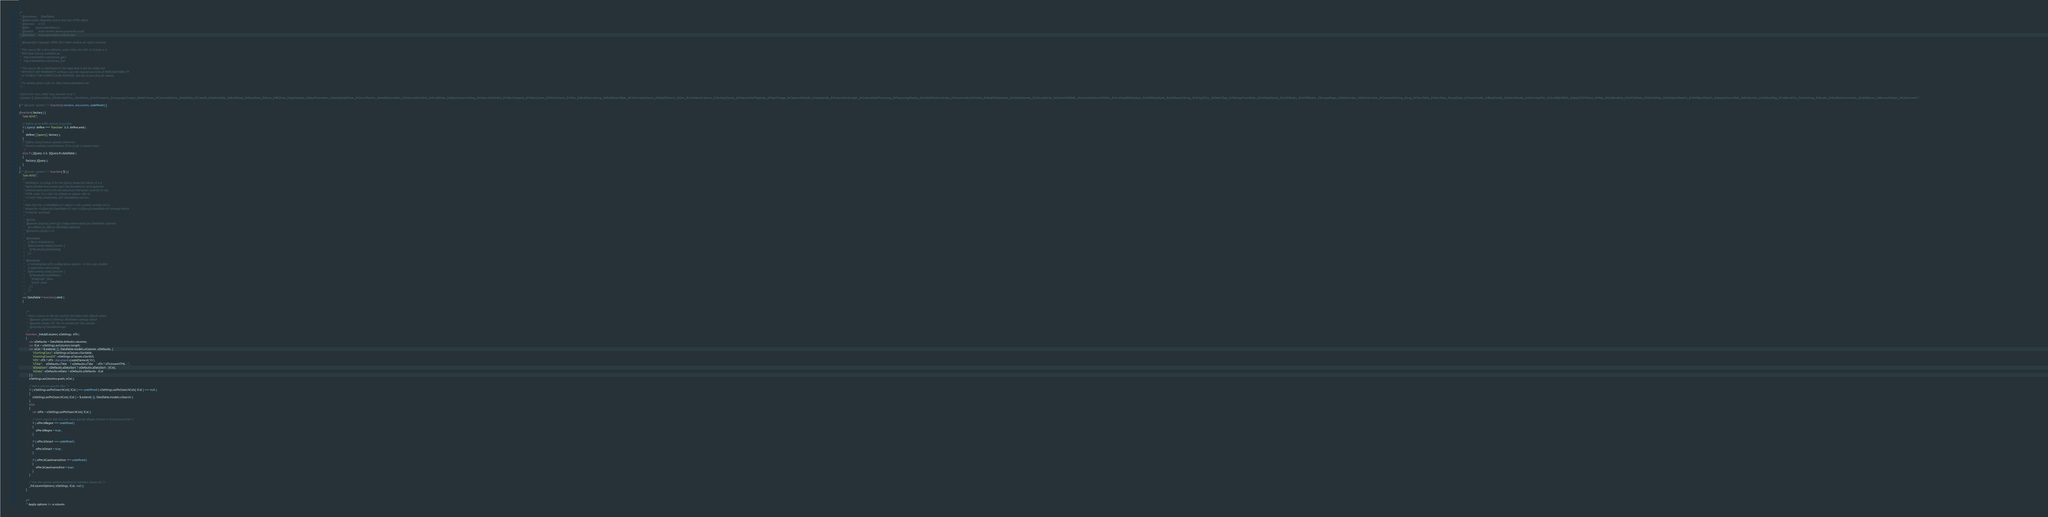<code> <loc_0><loc_0><loc_500><loc_500><_JavaScript_>/**
 * @summary     DataTables
 * @description Paginate, search and sort HTML tables
 * @version     1.9.4
 * @file        jquery.dataTables.js
 * @author      Allan Jardine (www.sprymedia.co.uk)
 * @contact     www.sprymedia.co.uk/contact
 *
 * @copyright Copyright 2008-2012 Allan Jardine, all rights reserved.
 *
 * This source file is free software, under either the GPL v2 license or a
 * BSD style license, available at:
 *   http://datatables.net/license_gpl2
 *   http://datatables.net/license_bsd
 * 
 * This source file is distributed in the hope that it will be useful, but 
 * WITHOUT ANY WARRANTY; without even the implied warranty of MERCHANTABILITY 
 * or FITNESS FOR A PARTICULAR PURPOSE. See the license files for details.
 * 
 * For details please refer to: http://www.datatables.net
 */

/*jslint evil: true, undef: true, browser: true */
/*globals $, jQuery,define,_fnExternApiFunc,_fnInitialise,_fnInitComplete,_fnLanguageCompat,_fnAddColumn,_fnColumnOptions,_fnAddData,_fnCreateTr,_fnGatherData,_fnBuildHead,_fnDrawHead,_fnDraw,_fnReDraw,_fnAjaxUpdate,_fnAjaxParameters,_fnAjaxUpdateDraw,_fnServerParams,_fnAddOptionsHtml,_fnFeatureHtmlTable,_fnScrollDraw,_fnAdjustColumnSizing,_fnFeatureHtmlFilter,_fnFilterComplete,_fnFilterCustom,_fnFilterColumn,_fnFilter,_fnBuildSearchArray,_fnBuildSearchRow,_fnFilterCreateSearch,_fnDataToSearch,_fnSort,_fnSortAttachListener,_fnSortingClasses,_fnFeatureHtmlPaginate,_fnPageChange,_fnFeatureHtmlInfo,_fnUpdateInfo,_fnFeatureHtmlLength,_fnFeatureHtmlProcessing,_fnProcessingDisplay,_fnVisibleToColumnIndex,_fnColumnIndexToVisible,_fnNodeToDataIndex,_fnVisbleColumns,_fnCalculateEnd,_fnConvertToWidth,_fnCalculateColumnWidths,_fnScrollingWidthAdjust,_fnGetWidestNode,_fnGetMaxLenString,_fnStringToCss,_fnDetectType,_fnSettingsFromNode,_fnGetDataMaster,_fnGetTrNodes,_fnGetTdNodes,_fnEscapeRegex,_fnDeleteIndex,_fnReOrderIndex,_fnColumnOrdering,_fnLog,_fnClearTable,_fnSaveState,_fnLoadState,_fnCreateCookie,_fnReadCookie,_fnDetectHeader,_fnGetUniqueThs,_fnScrollBarWidth,_fnApplyToChildren,_fnMap,_fnGetRowData,_fnGetCellData,_fnSetCellData,_fnGetObjectDataFn,_fnSetObjectDataFn,_fnApplyColumnDefs,_fnBindAction,_fnCallbackReg,_fnCallbackFire,_fnJsonString,_fnRender,_fnNodeToColumnIndex,_fnInfoMacros,_fnBrowserDetect,_fnGetColumns*/

(/** @lends <global> */function( window, document, undefined ) {

(function( factory ) {
	"use strict";

	// Define as an AMD module if possible
	if ( typeof define === 'function' && define.amd )
	{
		define( ['jquery'], factory );
	}
	/* Define using browser globals otherwise
	 * Prevent multiple instantiations if the script is loaded twice
	 */
	else if ( jQuery && !jQuery.fn.dataTable )
	{
		factory( jQuery );
	}
}
(/** @lends <global> */function( $ ) {
	"use strict";
	/** 
	 * DataTables is a plug-in for the jQuery Javascript library. It is a 
	 * highly flexible tool, based upon the foundations of progressive 
	 * enhancement, which will add advanced interaction controls to any 
	 * HTML table. For a full list of features please refer to
	 * <a href="http://datatables.net">DataTables.net</a>.
	 *
	 * Note that the <i>DataTable</i> object is not a global variable but is
	 * aliased to <i>jQuery.fn.DataTable</i> and <i>jQuery.fn.dataTable</i> through which 
	 * it may be  accessed.
	 *
	 *  @class
	 *  @param {object} [oInit={}] Configuration object for DataTables. Options
	 *    are defined by {@link DataTable.defaults}
	 *  @requires jQuery 1.3+
	 * 
	 *  @example
	 *    // Basic initialisation
	 *    $(document).ready( function {
	 *      $('#example').dataTable();
	 *    } );
	 *  
	 *  @example
	 *    // Initialisation with configuration options - in this case, disable
	 *    // pagination and sorting.
	 *    $(document).ready( function {
	 *      $('#example').dataTable( {
	 *        "bPaginate": false,
	 *        "bSort": false 
	 *      } );
	 *    } );
	 */
	var DataTable = function( oInit )
	{
		
		
		/**
		 * Add a column to the list used for the table with default values
		 *  @param {object} oSettings dataTables settings object
		 *  @param {node} nTh The th element for this column
		 *  @memberof DataTable#oApi
		 */
		function _fnAddColumn( oSettings, nTh )
		{
			var oDefaults = DataTable.defaults.columns;
			var iCol = oSettings.aoColumns.length;
			var oCol = $.extend( {}, DataTable.models.oColumn, oDefaults, {
				"sSortingClass": oSettings.oClasses.sSortable,
				"sSortingClassJUI": oSettings.oClasses.sSortJUI,
				"nTh": nTh ? nTh : document.createElement('th'),
				"sTitle":    oDefaults.sTitle    ? oDefaults.sTitle    : nTh ? nTh.innerHTML : '',
				"aDataSort": oDefaults.aDataSort ? oDefaults.aDataSort : [iCol],
				"mData": oDefaults.mData ? oDefaults.oDefaults : iCol
			} );
			oSettings.aoColumns.push( oCol );
			
			/* Add a column specific filter */
			if ( oSettings.aoPreSearchCols[ iCol ] === undefined || oSettings.aoPreSearchCols[ iCol ] === null )
			{
				oSettings.aoPreSearchCols[ iCol ] = $.extend( {}, DataTable.models.oSearch );
			}
			else
			{
				var oPre = oSettings.aoPreSearchCols[ iCol ];
				
				/* Don't require that the user must specify bRegex, bSmart or bCaseInsensitive */
				if ( oPre.bRegex === undefined )
				{
					oPre.bRegex = true;
				}
				
				if ( oPre.bSmart === undefined )
				{
					oPre.bSmart = true;
				}
				
				if ( oPre.bCaseInsensitive === undefined )
				{
					oPre.bCaseInsensitive = true;
				}
			}
			
			/* Use the column options function to initialise classes etc */
			_fnColumnOptions( oSettings, iCol, null );
		}
		
		
		/**
		 * Apply options for a column</code> 